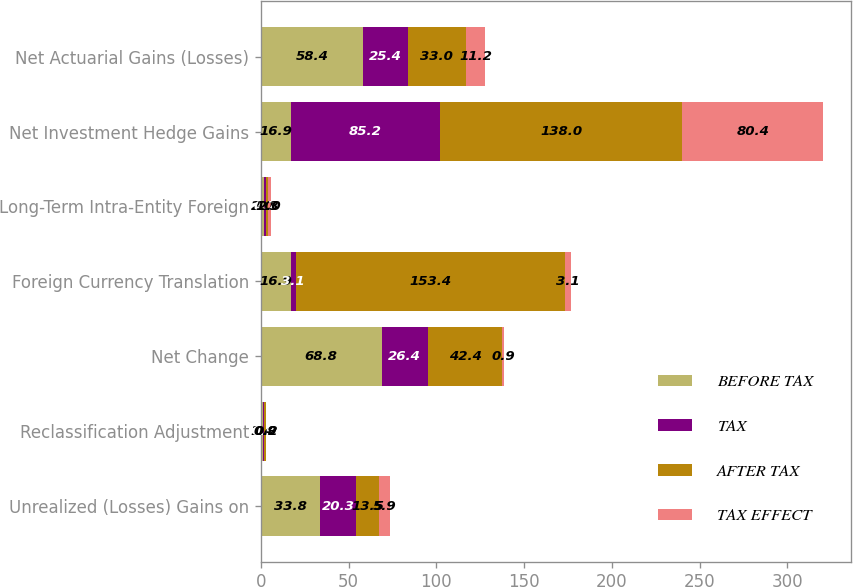Convert chart. <chart><loc_0><loc_0><loc_500><loc_500><stacked_bar_chart><ecel><fcel>Unrealized (Losses) Gains on<fcel>Reclassification Adjustment<fcel>Net Change<fcel>Foreign Currency Translation<fcel>Long-Term Intra-Entity Foreign<fcel>Net Investment Hedge Gains<fcel>Net Actuarial Gains (Losses)<nl><fcel>BEFORE TAX<fcel>33.8<fcel>1.4<fcel>68.8<fcel>16.9<fcel>2<fcel>16.9<fcel>58.4<nl><fcel>TAX<fcel>20.3<fcel>0.5<fcel>26.4<fcel>3.1<fcel>0.7<fcel>85.2<fcel>25.4<nl><fcel>AFTER TAX<fcel>13.5<fcel>0.9<fcel>42.4<fcel>153.4<fcel>1.3<fcel>138<fcel>33<nl><fcel>TAX EFFECT<fcel>5.9<fcel>0.2<fcel>0.9<fcel>3.1<fcel>2<fcel>80.4<fcel>11.2<nl></chart> 